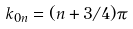<formula> <loc_0><loc_0><loc_500><loc_500>k _ { 0 n } = ( n + 3 / 4 ) \pi</formula> 